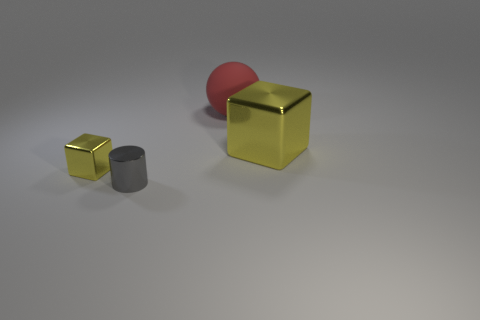Add 1 red things. How many objects exist? 5 Subtract all balls. How many objects are left? 3 Add 3 small gray things. How many small gray things exist? 4 Subtract 0 cyan cubes. How many objects are left? 4 Subtract all cylinders. Subtract all yellow cubes. How many objects are left? 1 Add 4 things. How many things are left? 8 